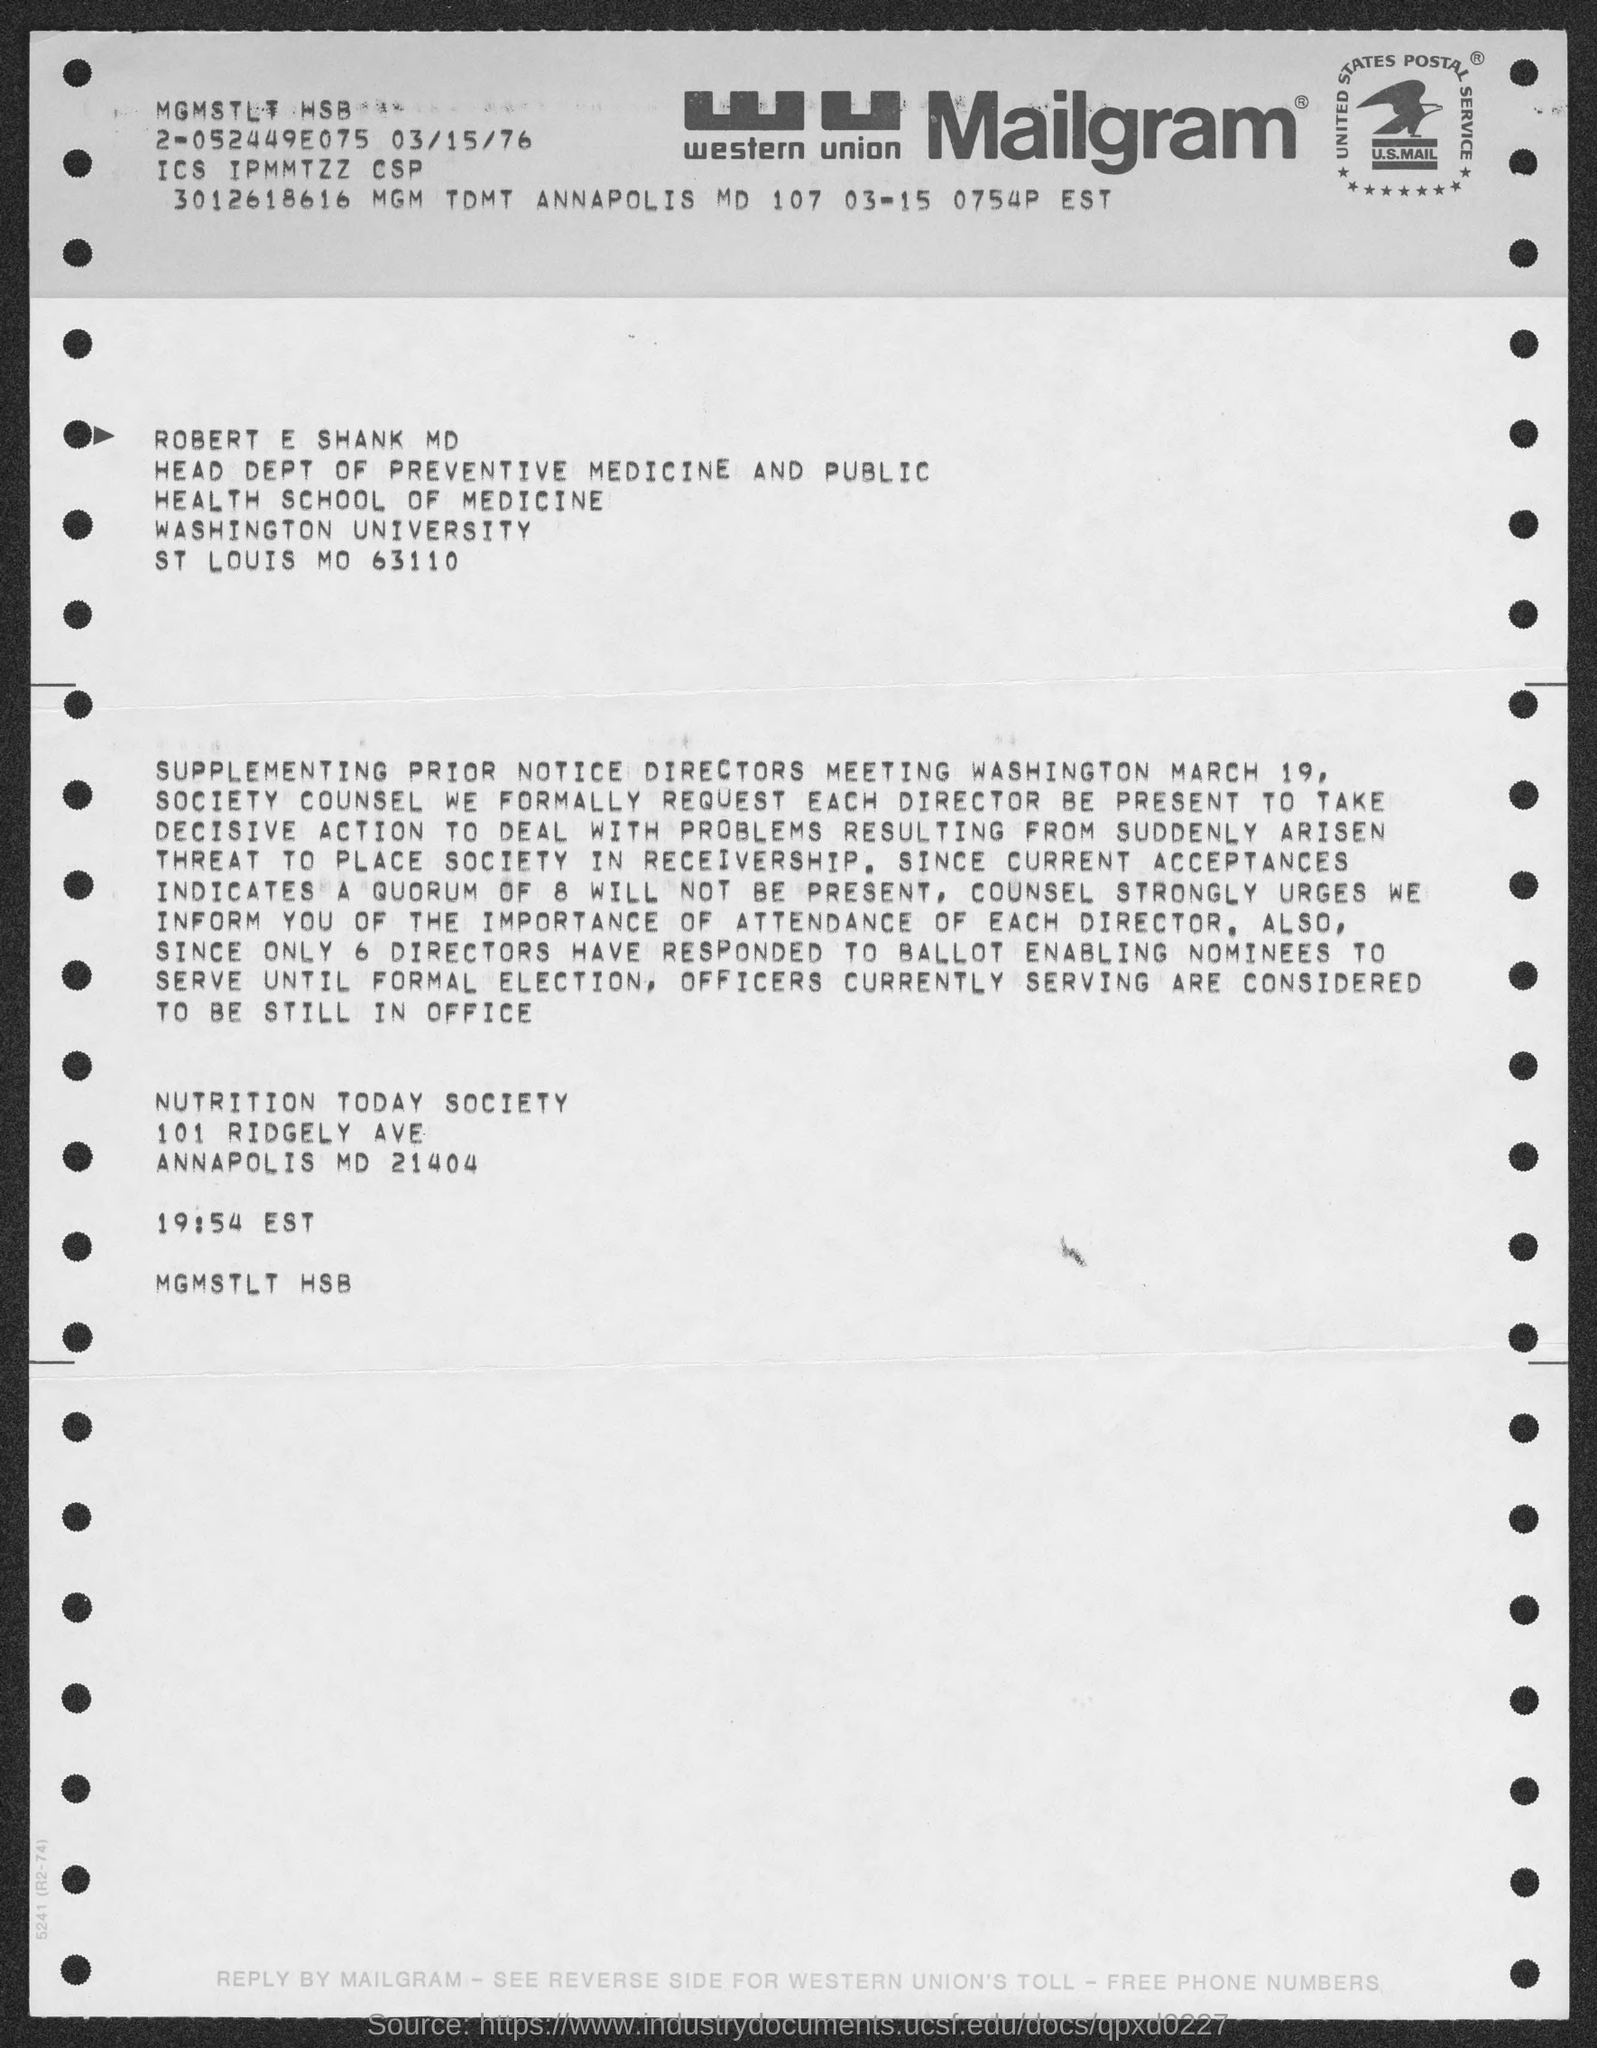What kind of communication is this ?
Offer a terse response. Mailgram. What is the name mentioned in the mailgram?
Your answer should be very brief. ROBERT E SHANK MD. 